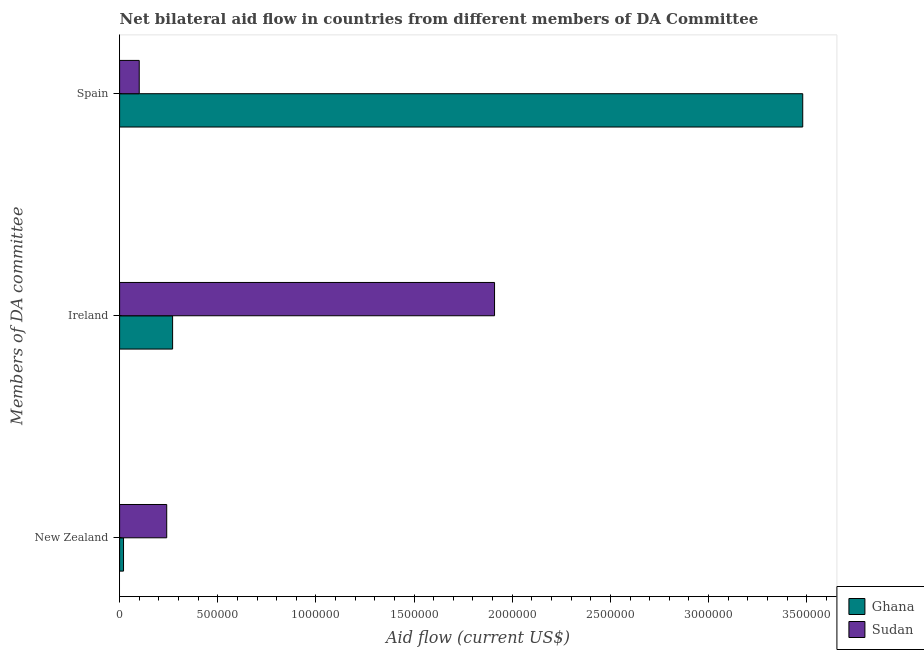How many different coloured bars are there?
Your answer should be compact. 2. How many groups of bars are there?
Offer a terse response. 3. Are the number of bars per tick equal to the number of legend labels?
Your answer should be very brief. Yes. How many bars are there on the 2nd tick from the bottom?
Your response must be concise. 2. What is the amount of aid provided by spain in Sudan?
Offer a very short reply. 1.00e+05. Across all countries, what is the maximum amount of aid provided by new zealand?
Make the answer very short. 2.40e+05. Across all countries, what is the minimum amount of aid provided by new zealand?
Provide a succinct answer. 2.00e+04. In which country was the amount of aid provided by ireland maximum?
Offer a terse response. Sudan. In which country was the amount of aid provided by spain minimum?
Keep it short and to the point. Sudan. What is the total amount of aid provided by ireland in the graph?
Give a very brief answer. 2.18e+06. What is the difference between the amount of aid provided by spain in Ghana and that in Sudan?
Make the answer very short. 3.38e+06. What is the difference between the amount of aid provided by ireland in Sudan and the amount of aid provided by new zealand in Ghana?
Give a very brief answer. 1.89e+06. What is the average amount of aid provided by new zealand per country?
Your answer should be compact. 1.30e+05. What is the difference between the amount of aid provided by ireland and amount of aid provided by spain in Ghana?
Ensure brevity in your answer.  -3.21e+06. What is the ratio of the amount of aid provided by ireland in Ghana to that in Sudan?
Give a very brief answer. 0.14. Is the amount of aid provided by spain in Ghana less than that in Sudan?
Keep it short and to the point. No. What is the difference between the highest and the second highest amount of aid provided by spain?
Offer a very short reply. 3.38e+06. What is the difference between the highest and the lowest amount of aid provided by new zealand?
Give a very brief answer. 2.20e+05. In how many countries, is the amount of aid provided by spain greater than the average amount of aid provided by spain taken over all countries?
Your answer should be compact. 1. What does the 1st bar from the bottom in New Zealand represents?
Offer a terse response. Ghana. Is it the case that in every country, the sum of the amount of aid provided by new zealand and amount of aid provided by ireland is greater than the amount of aid provided by spain?
Make the answer very short. No. How many bars are there?
Offer a terse response. 6. How many countries are there in the graph?
Offer a very short reply. 2. What is the difference between two consecutive major ticks on the X-axis?
Make the answer very short. 5.00e+05. Does the graph contain any zero values?
Give a very brief answer. No. What is the title of the graph?
Ensure brevity in your answer.  Net bilateral aid flow in countries from different members of DA Committee. What is the label or title of the X-axis?
Keep it short and to the point. Aid flow (current US$). What is the label or title of the Y-axis?
Offer a very short reply. Members of DA committee. What is the Aid flow (current US$) of Ghana in New Zealand?
Your answer should be compact. 2.00e+04. What is the Aid flow (current US$) in Sudan in New Zealand?
Ensure brevity in your answer.  2.40e+05. What is the Aid flow (current US$) in Ghana in Ireland?
Your answer should be very brief. 2.70e+05. What is the Aid flow (current US$) of Sudan in Ireland?
Provide a succinct answer. 1.91e+06. What is the Aid flow (current US$) of Ghana in Spain?
Make the answer very short. 3.48e+06. Across all Members of DA committee, what is the maximum Aid flow (current US$) in Ghana?
Provide a succinct answer. 3.48e+06. Across all Members of DA committee, what is the maximum Aid flow (current US$) of Sudan?
Ensure brevity in your answer.  1.91e+06. Across all Members of DA committee, what is the minimum Aid flow (current US$) in Ghana?
Keep it short and to the point. 2.00e+04. What is the total Aid flow (current US$) in Ghana in the graph?
Your answer should be very brief. 3.77e+06. What is the total Aid flow (current US$) of Sudan in the graph?
Keep it short and to the point. 2.25e+06. What is the difference between the Aid flow (current US$) of Sudan in New Zealand and that in Ireland?
Ensure brevity in your answer.  -1.67e+06. What is the difference between the Aid flow (current US$) of Ghana in New Zealand and that in Spain?
Offer a terse response. -3.46e+06. What is the difference between the Aid flow (current US$) of Ghana in Ireland and that in Spain?
Give a very brief answer. -3.21e+06. What is the difference between the Aid flow (current US$) of Sudan in Ireland and that in Spain?
Make the answer very short. 1.81e+06. What is the difference between the Aid flow (current US$) of Ghana in New Zealand and the Aid flow (current US$) of Sudan in Ireland?
Make the answer very short. -1.89e+06. What is the difference between the Aid flow (current US$) of Ghana in New Zealand and the Aid flow (current US$) of Sudan in Spain?
Make the answer very short. -8.00e+04. What is the difference between the Aid flow (current US$) of Ghana in Ireland and the Aid flow (current US$) of Sudan in Spain?
Keep it short and to the point. 1.70e+05. What is the average Aid flow (current US$) of Ghana per Members of DA committee?
Offer a terse response. 1.26e+06. What is the average Aid flow (current US$) of Sudan per Members of DA committee?
Provide a short and direct response. 7.50e+05. What is the difference between the Aid flow (current US$) of Ghana and Aid flow (current US$) of Sudan in Ireland?
Give a very brief answer. -1.64e+06. What is the difference between the Aid flow (current US$) of Ghana and Aid flow (current US$) of Sudan in Spain?
Offer a very short reply. 3.38e+06. What is the ratio of the Aid flow (current US$) in Ghana in New Zealand to that in Ireland?
Your answer should be compact. 0.07. What is the ratio of the Aid flow (current US$) in Sudan in New Zealand to that in Ireland?
Give a very brief answer. 0.13. What is the ratio of the Aid flow (current US$) in Ghana in New Zealand to that in Spain?
Provide a succinct answer. 0.01. What is the ratio of the Aid flow (current US$) of Sudan in New Zealand to that in Spain?
Your response must be concise. 2.4. What is the ratio of the Aid flow (current US$) in Ghana in Ireland to that in Spain?
Your response must be concise. 0.08. What is the ratio of the Aid flow (current US$) in Sudan in Ireland to that in Spain?
Offer a very short reply. 19.1. What is the difference between the highest and the second highest Aid flow (current US$) in Ghana?
Provide a succinct answer. 3.21e+06. What is the difference between the highest and the second highest Aid flow (current US$) of Sudan?
Your answer should be very brief. 1.67e+06. What is the difference between the highest and the lowest Aid flow (current US$) in Ghana?
Give a very brief answer. 3.46e+06. What is the difference between the highest and the lowest Aid flow (current US$) of Sudan?
Your answer should be very brief. 1.81e+06. 